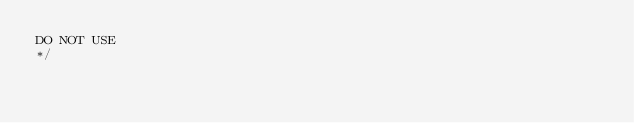Convert code to text. <code><loc_0><loc_0><loc_500><loc_500><_JavaScript_>DO NOT USE 
*/
</code> 